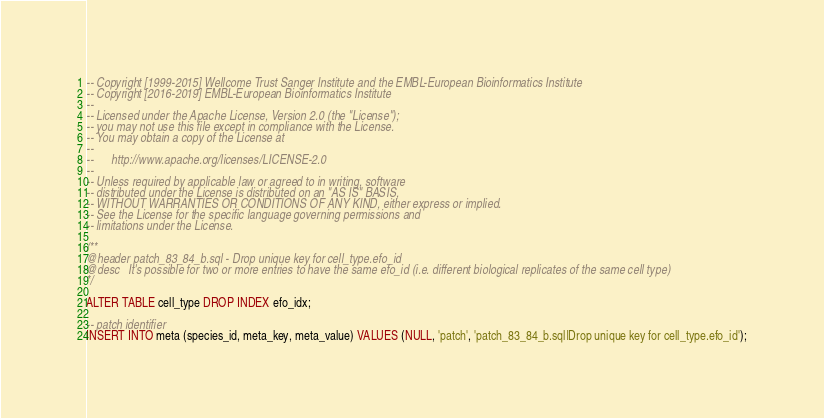Convert code to text. <code><loc_0><loc_0><loc_500><loc_500><_SQL_>-- Copyright [1999-2015] Wellcome Trust Sanger Institute and the EMBL-European Bioinformatics Institute
-- Copyright [2016-2019] EMBL-European Bioinformatics Institute
--
-- Licensed under the Apache License, Version 2.0 (the "License");
-- you may not use this file except in compliance with the License.
-- You may obtain a copy of the License at
--
--      http://www.apache.org/licenses/LICENSE-2.0
--
-- Unless required by applicable law or agreed to in writing, software
-- distributed under the License is distributed on an "AS IS" BASIS,
-- WITHOUT WARRANTIES OR CONDITIONS OF ANY KIND, either express or implied.
-- See the License for the specific language governing permissions and
-- limitations under the License.

/**
@header patch_83_84_b.sql - Drop unique key for cell_type.efo_id
@desc   It's possible for two or more entries to have the same efo_id (i.e. different biological replicates of the same cell type)
*/

ALTER TABLE cell_type DROP INDEX efo_idx;

-- patch identifier
INSERT INTO meta (species_id, meta_key, meta_value) VALUES (NULL, 'patch', 'patch_83_84_b.sql|Drop unique key for cell_type.efo_id');
</code> 